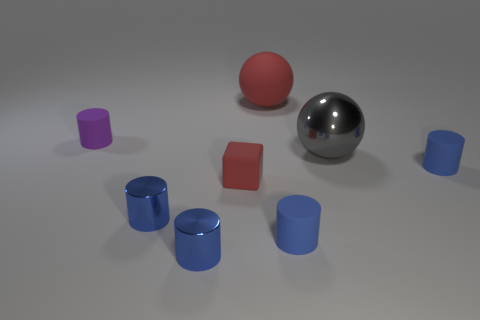Subtract all brown spheres. How many blue cylinders are left? 4 Subtract all purple cylinders. How many cylinders are left? 4 Subtract all purple cylinders. How many cylinders are left? 4 Subtract 2 cylinders. How many cylinders are left? 3 Add 1 small red rubber cubes. How many objects exist? 9 Subtract all purple cylinders. Subtract all cyan blocks. How many cylinders are left? 4 Subtract all cubes. How many objects are left? 7 Subtract all red balls. Subtract all small red rubber objects. How many objects are left? 6 Add 4 red matte spheres. How many red matte spheres are left? 5 Add 6 rubber cylinders. How many rubber cylinders exist? 9 